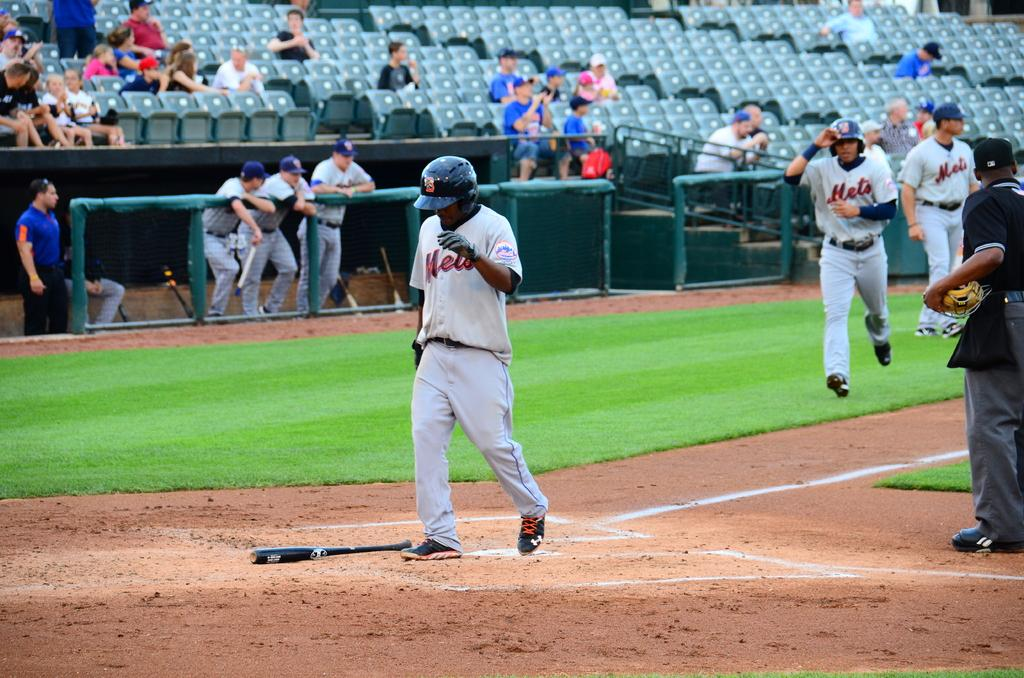<image>
Give a short and clear explanation of the subsequent image. Baseball player for the Mets standing next to a bat. 